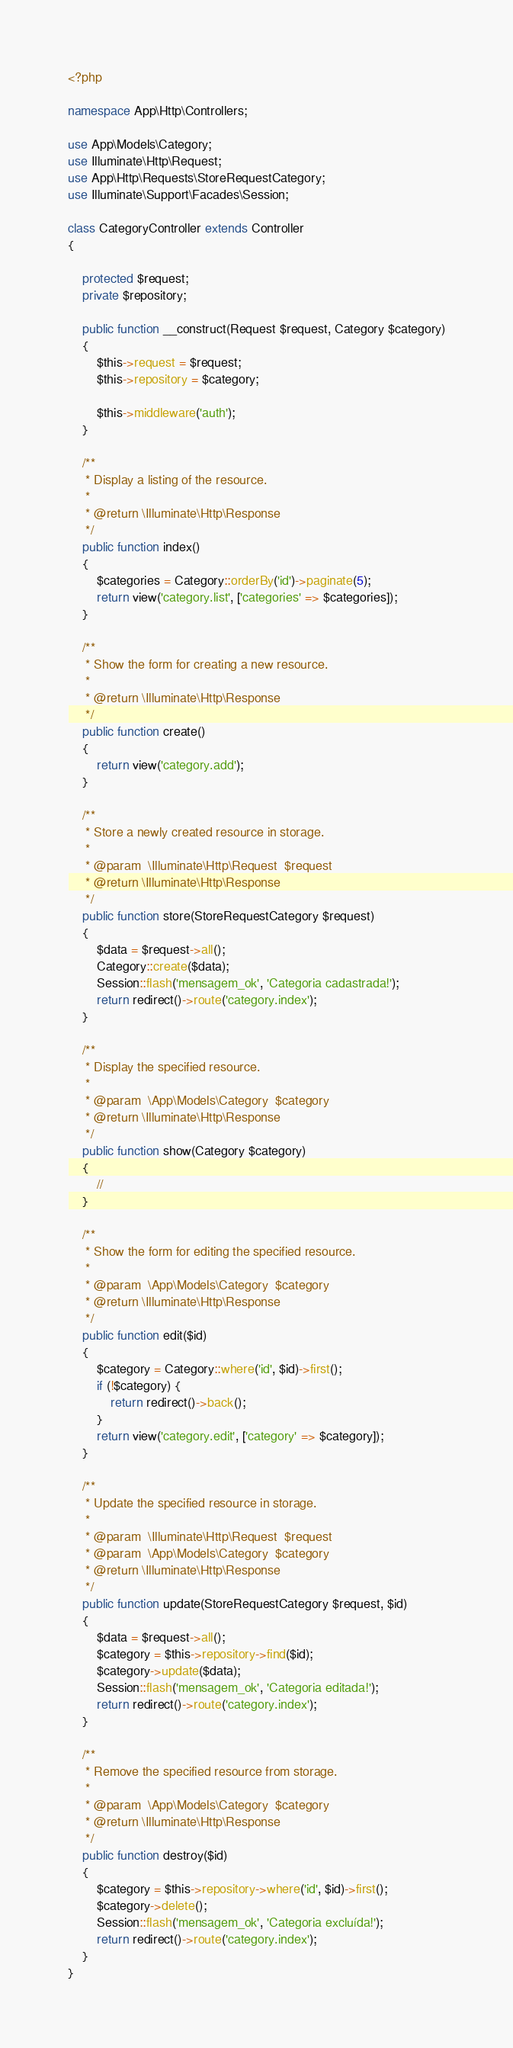Convert code to text. <code><loc_0><loc_0><loc_500><loc_500><_PHP_><?php

namespace App\Http\Controllers;

use App\Models\Category;
use Illuminate\Http\Request;
use App\Http\Requests\StoreRequestCategory;
use Illuminate\Support\Facades\Session;

class CategoryController extends Controller
{

    protected $request;
    private $repository;

    public function __construct(Request $request, Category $category)
    {
        $this->request = $request;
        $this->repository = $category;

        $this->middleware('auth');
    }

    /**
     * Display a listing of the resource.
     *
     * @return \Illuminate\Http\Response
     */
    public function index()
    {
        $categories = Category::orderBy('id')->paginate(5);
        return view('category.list', ['categories' => $categories]);
    }

    /**
     * Show the form for creating a new resource.
     *
     * @return \Illuminate\Http\Response
     */
    public function create()
    {
        return view('category.add');
    }

    /**
     * Store a newly created resource in storage.
     *
     * @param  \Illuminate\Http\Request  $request
     * @return \Illuminate\Http\Response
     */
    public function store(StoreRequestCategory $request)
    {
        $data = $request->all();
        Category::create($data);
        Session::flash('mensagem_ok', 'Categoria cadastrada!');
        return redirect()->route('category.index');
    }

    /**
     * Display the specified resource.
     *
     * @param  \App\Models\Category  $category
     * @return \Illuminate\Http\Response
     */
    public function show(Category $category)
    {
        //
    }

    /**
     * Show the form for editing the specified resource.
     *
     * @param  \App\Models\Category  $category
     * @return \Illuminate\Http\Response
     */
    public function edit($id)
    {
        $category = Category::where('id', $id)->first();
        if (!$category) {
            return redirect()->back();
        }
        return view('category.edit', ['category' => $category]);
    }

    /**
     * Update the specified resource in storage.
     *
     * @param  \Illuminate\Http\Request  $request
     * @param  \App\Models\Category  $category
     * @return \Illuminate\Http\Response
     */
    public function update(StoreRequestCategory $request, $id)
    {
        $data = $request->all();
        $category = $this->repository->find($id);
        $category->update($data);
        Session::flash('mensagem_ok', 'Categoria editada!');
        return redirect()->route('category.index');
    }

    /**
     * Remove the specified resource from storage.
     *
     * @param  \App\Models\Category  $category
     * @return \Illuminate\Http\Response
     */
    public function destroy($id)
    {
        $category = $this->repository->where('id', $id)->first();
        $category->delete();
        Session::flash('mensagem_ok', 'Categoria excluída!');
        return redirect()->route('category.index');
    }
}
</code> 